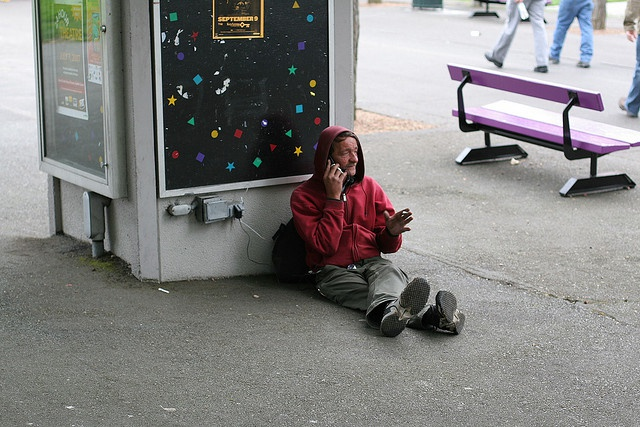Describe the objects in this image and their specific colors. I can see people in tan, black, maroon, gray, and darkgray tones, bench in tan, lavender, black, and purple tones, backpack in tan, black, and gray tones, people in tan, lavender, darkgray, and lightgray tones, and people in tan, gray, lightblue, and darkgray tones in this image. 